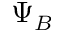Convert formula to latex. <formula><loc_0><loc_0><loc_500><loc_500>\Psi _ { B }</formula> 